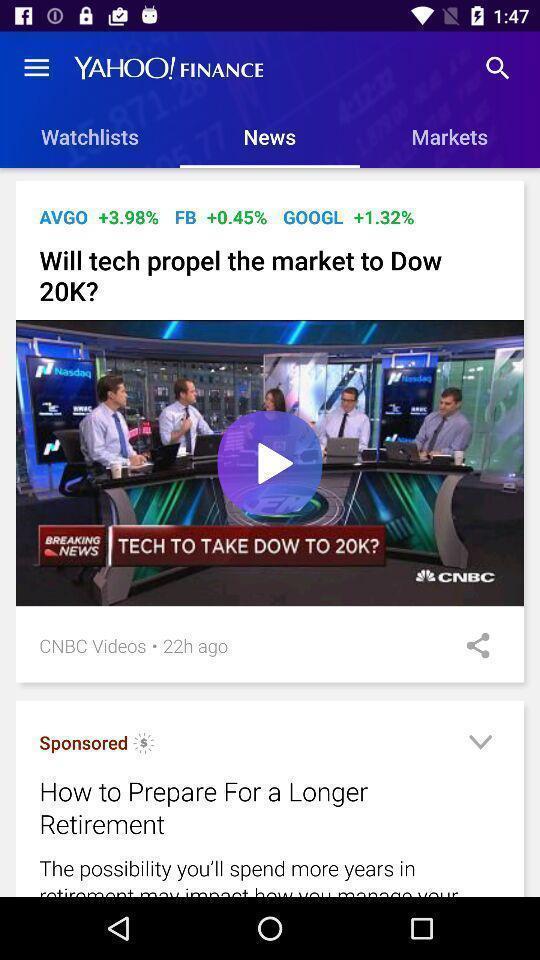Describe this image in words. Page showing videos in an online news app. 